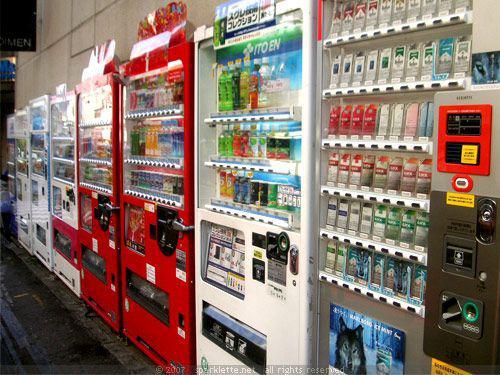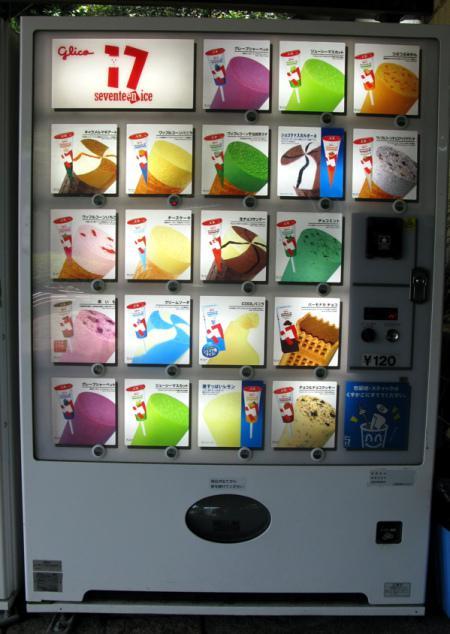The first image is the image on the left, the second image is the image on the right. For the images shown, is this caption "One of the images contains more than one vending machine." true? Answer yes or no. Yes. The first image is the image on the left, the second image is the image on the right. Given the left and right images, does the statement "There is a red vending machine in one of the images" hold true? Answer yes or no. Yes. 